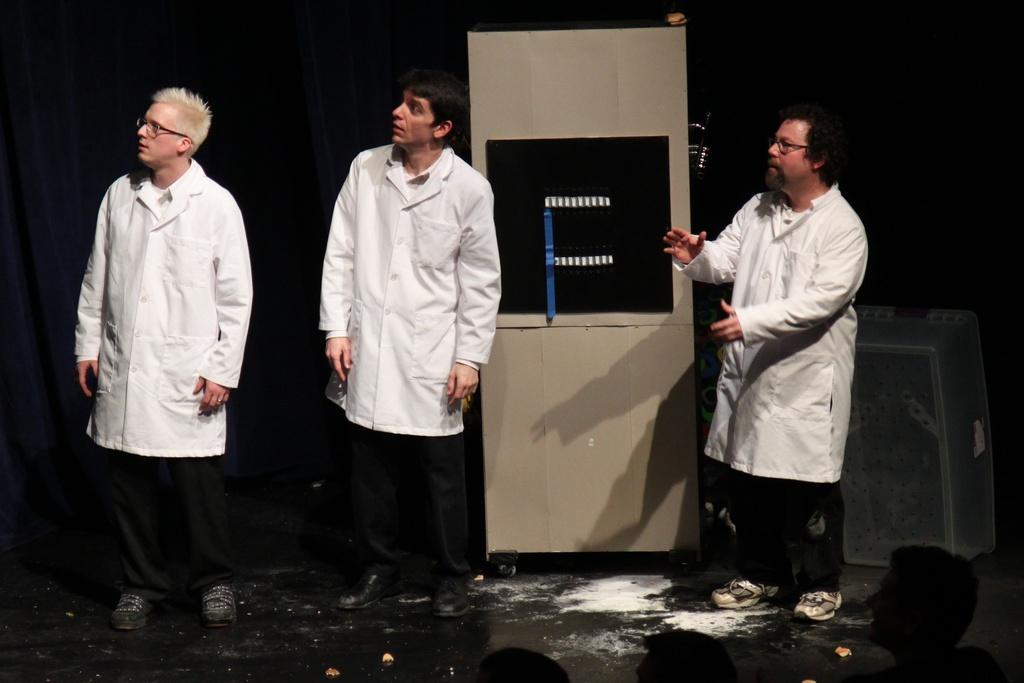How many people are in the image? There are three men in the image. Can you describe the object behind the men? Unfortunately, the facts provided do not give any details about the object behind the men. How many bubbles can be seen floating around the men in the image? There are no bubbles present in the image. 